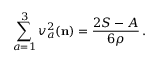<formula> <loc_0><loc_0><loc_500><loc_500>\sum _ { a = 1 } ^ { 3 } v _ { a } ^ { 2 } ( { n } ) = \frac { 2 S - A } { 6 \rho } \, .</formula> 